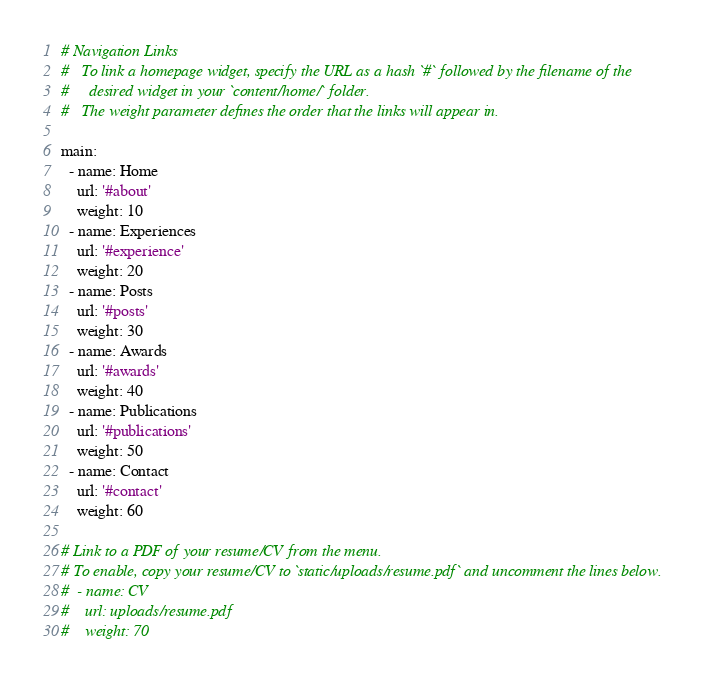<code> <loc_0><loc_0><loc_500><loc_500><_YAML_># Navigation Links
#   To link a homepage widget, specify the URL as a hash `#` followed by the filename of the
#     desired widget in your `content/home/` folder.
#   The weight parameter defines the order that the links will appear in.

main:
  - name: Home
    url: '#about'
    weight: 10
  - name: Experiences
    url: '#experience'
    weight: 20
  - name: Posts
    url: '#posts'
    weight: 30
  - name: Awards
    url: '#awards'
    weight: 40
  - name: Publications
    url: '#publications'
    weight: 50
  - name: Contact
    url: '#contact'
    weight: 60

# Link to a PDF of your resume/CV from the menu.
# To enable, copy your resume/CV to `static/uploads/resume.pdf` and uncomment the lines below.
#  - name: CV
#    url: uploads/resume.pdf
#    weight: 70
</code> 